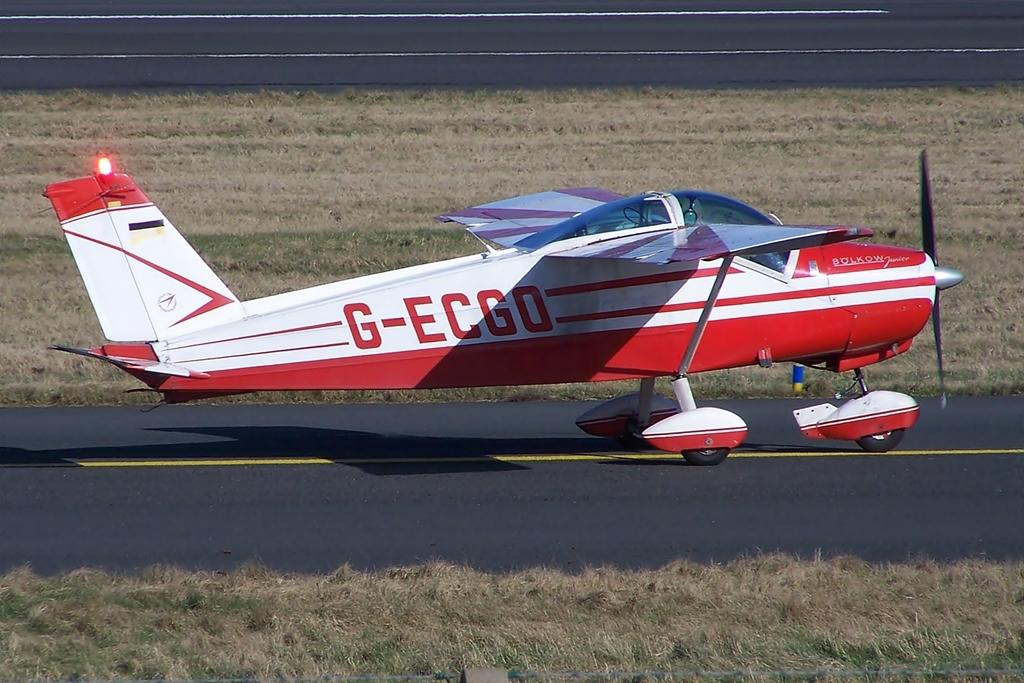<image>
Give a short and clear explanation of the subsequent image. A small plane on what looks like a road, model G-ECGO. 